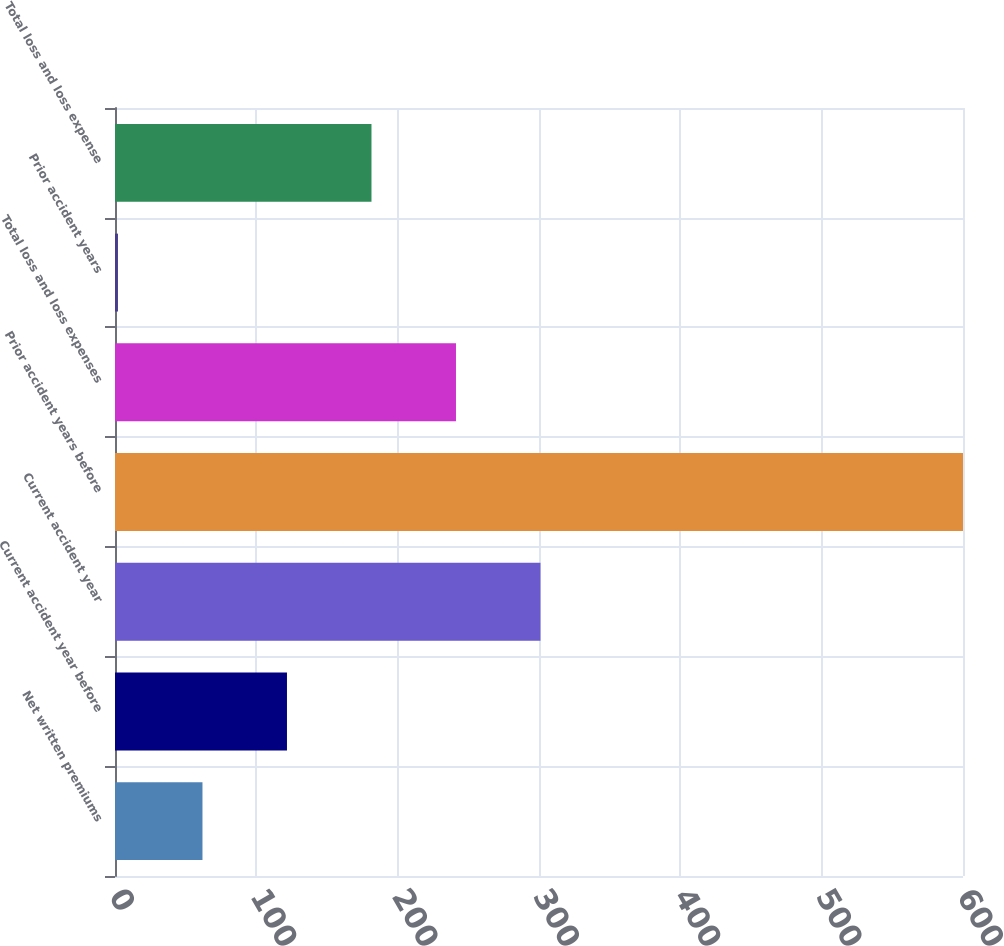Convert chart to OTSL. <chart><loc_0><loc_0><loc_500><loc_500><bar_chart><fcel>Net written premiums<fcel>Current accident year before<fcel>Current accident year<fcel>Prior accident years before<fcel>Total loss and loss expenses<fcel>Prior accident years<fcel>Total loss and loss expense<nl><fcel>61.89<fcel>121.68<fcel>301.05<fcel>600<fcel>241.26<fcel>2.1<fcel>181.47<nl></chart> 